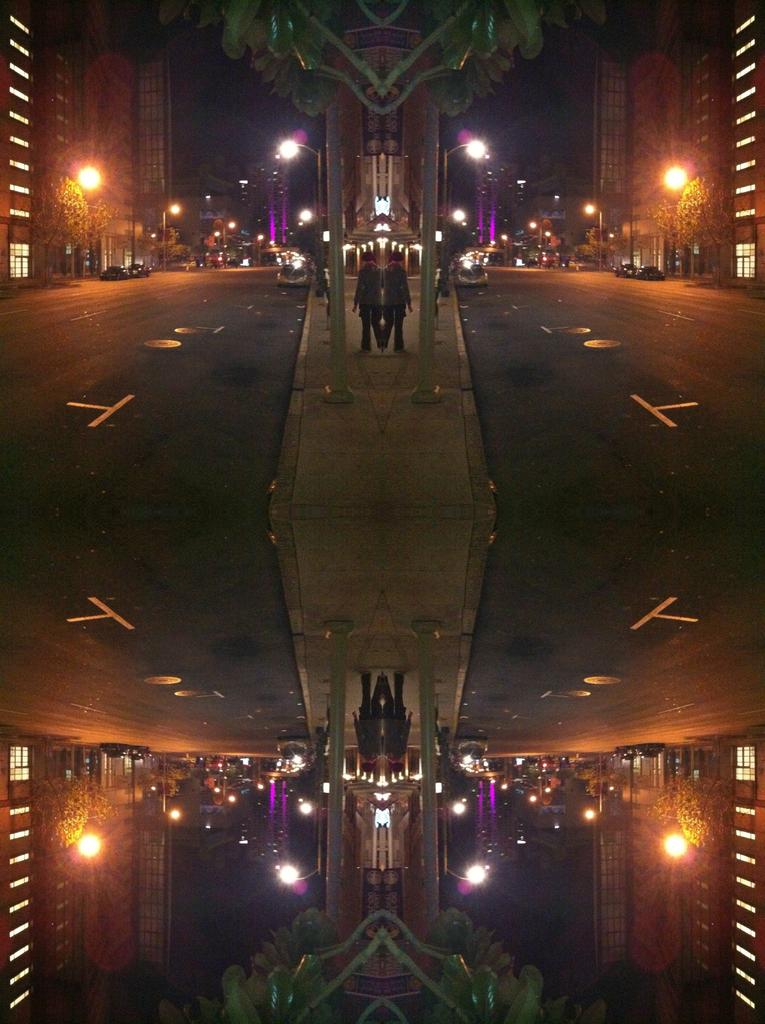What is unique about the image? The image is an edited mirror reflection. What can be seen in the sky in the image? There are lights visible in the image. What structures are present in the image? There are poles, buildings, and trees in the image. What is the primary mode of transportation in the image? There is a road in the image, which suggests that vehicles or pedestrians might be using it for transportation. How many persons are visible in the image? There are persons in the image, but the exact number cannot be determined from the provided facts. What is the coefficient of friction between the persons and the road in the image? The image does not provide information about the coefficient of friction between the persons and the road, as it is a static image and does not show any movement or interaction between the persons and the road. 